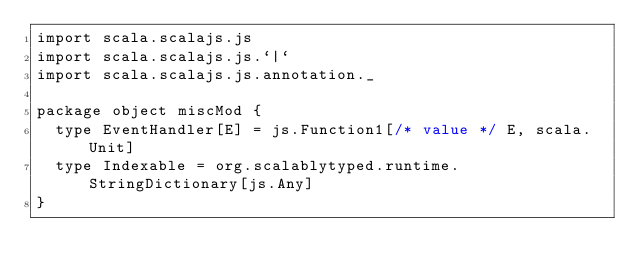Convert code to text. <code><loc_0><loc_0><loc_500><loc_500><_Scala_>import scala.scalajs.js
import scala.scalajs.js.`|`
import scala.scalajs.js.annotation._

package object miscMod {
  type EventHandler[E] = js.Function1[/* value */ E, scala.Unit]
  type Indexable = org.scalablytyped.runtime.StringDictionary[js.Any]
}
</code> 